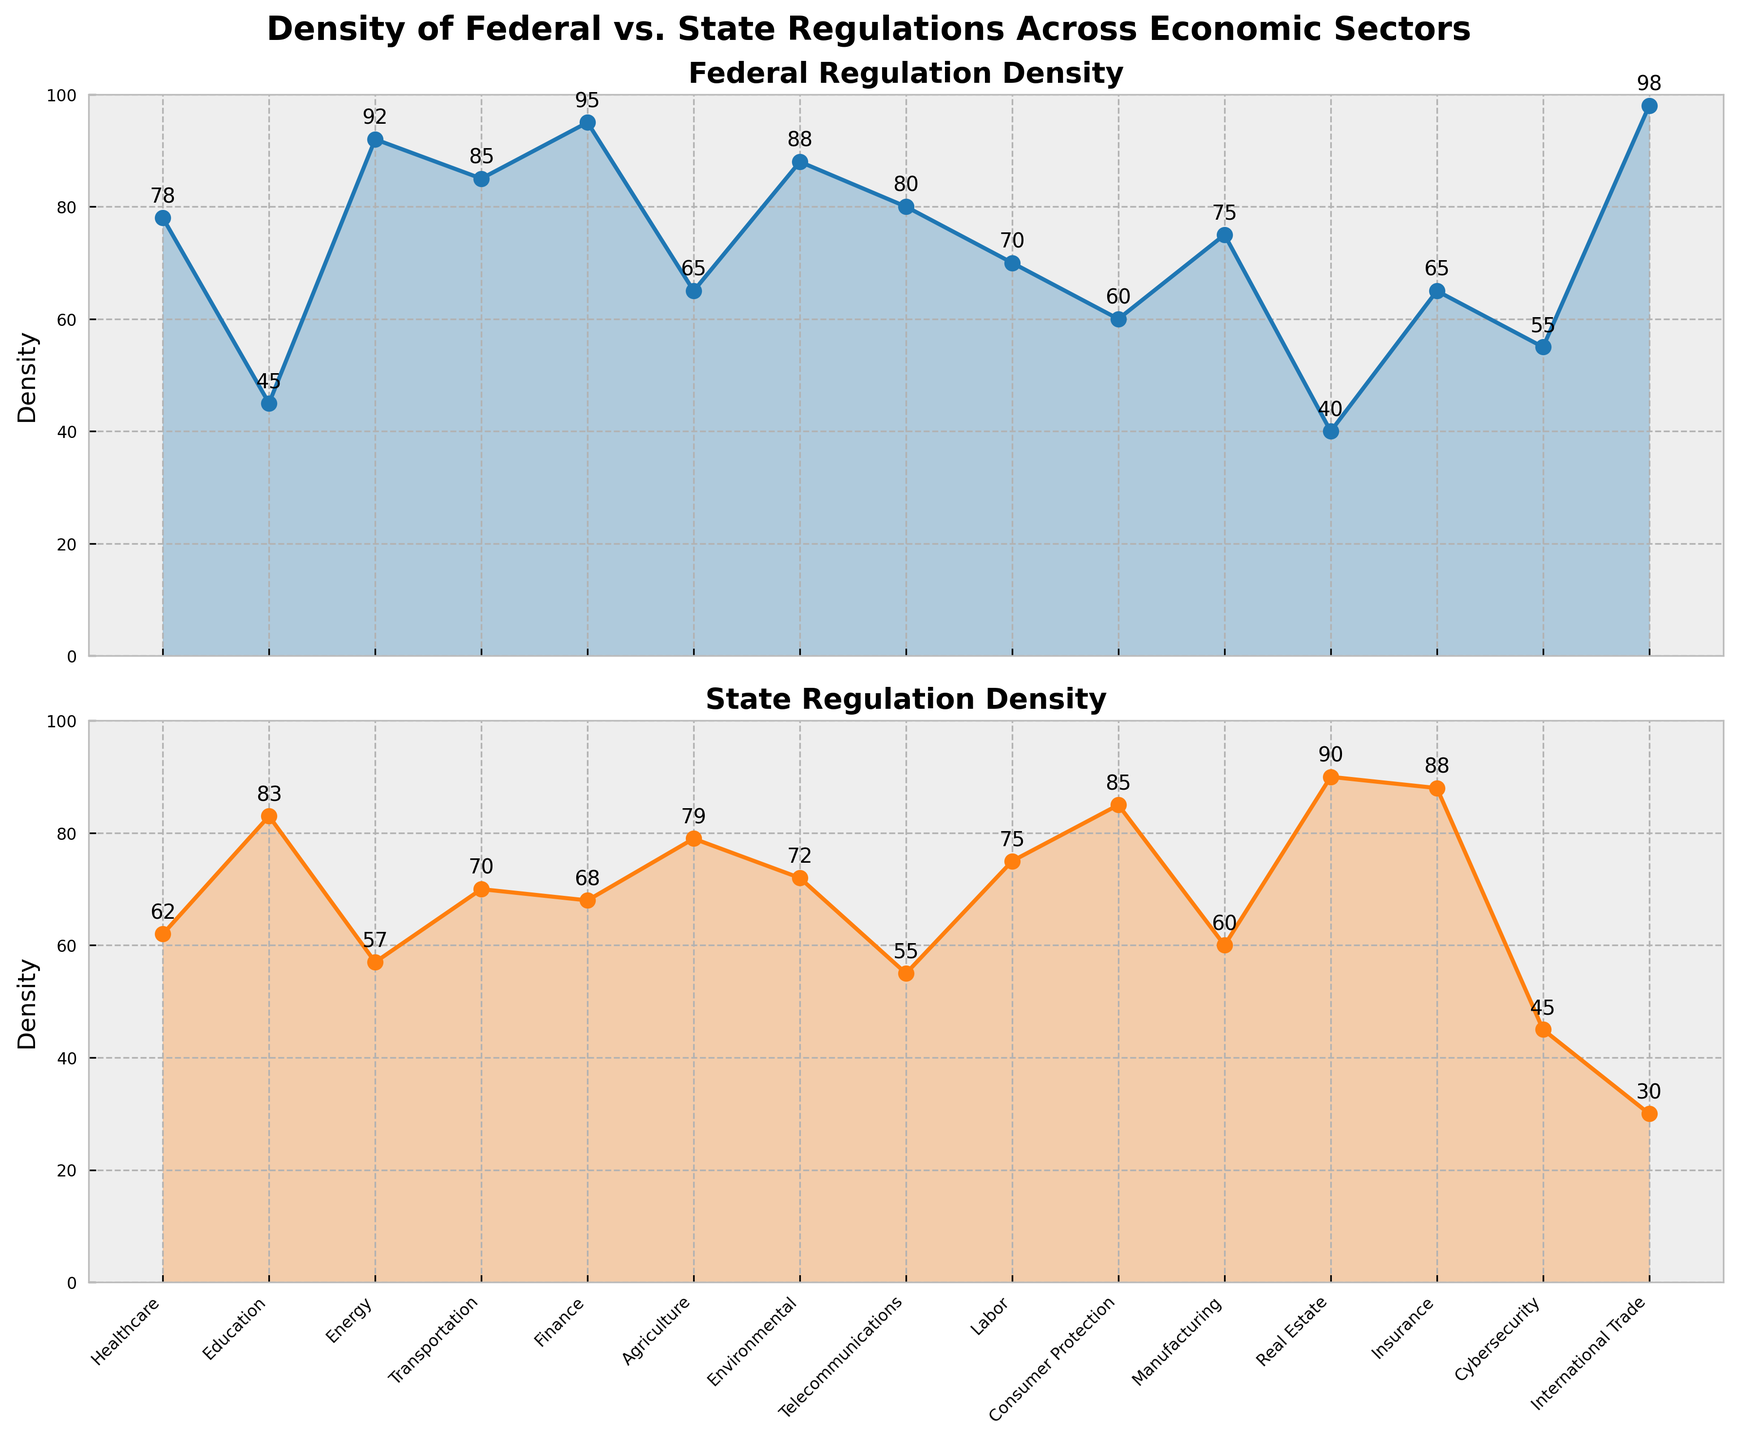What is the title of the top plot? The title of the top plot is displayed at the top center of the plot. It reads 'Federal Regulation Density'.
Answer: Federal Regulation Density How many economic sectors are represented in the plots? To determine the number of economic sectors, count the distinct categories on the x-axis. There are 15 sectors listed.
Answer: 15 Which economic sector has the highest density of federal regulations? Look for the tallest point in the top plot labelled 'Federal Regulation Density'. The highest value is 98 for 'International Trade'.
Answer: International Trade What is the density value for state regulations in the Education sector? Find the label 'Education' on the x-axis of the bottom plot and observe the corresponding point on the line. The value next to the point is 83.
Answer: 83 What is the difference in regulation density between federal and state levels in the Energy sector? Locate 'Energy' in both plots and note the values. Federal density is 92, and state density is 57. Subtract state density from federal density: 92 - 57 = 35.
Answer: 35 Which sector has nearly equal densities for both federal and state regulations? Compare the two plots and look for sectors where points are close together. 'Labor' has values 70 (federal) and 75 (state), which are nearly equal.
Answer: Labor Which sectors have higher state regulation densities compared to federal regulation densities? Compare data points for all sectors in both plots. 'Education', 'Agriculture', 'Consumer Protection', 'Real Estate', and 'Insurance' show higher state densities.
Answer: Education, Agriculture, Consumer Protection, Real Estate, Insurance What is the combined regulation density (federal + state) for the Finance sector? Add the federal (95) and state (68) densities for the 'Finance' sector. 95 + 68 = 163.
Answer: 163 Is the overall trend in federal regulation density similar to state regulation density across the sectors? Visually compare the general shapes of both plots. Both plots show a variable pattern, but there are no consistent trends that match across all sectors.
Answer: No Which sector has the lowest density of state regulations, and what is the value? Find the lowest point in the bottom plot. The lowest value is 30 for 'International Trade'.
Answer: International Trade, 30 